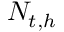<formula> <loc_0><loc_0><loc_500><loc_500>N _ { t , h }</formula> 